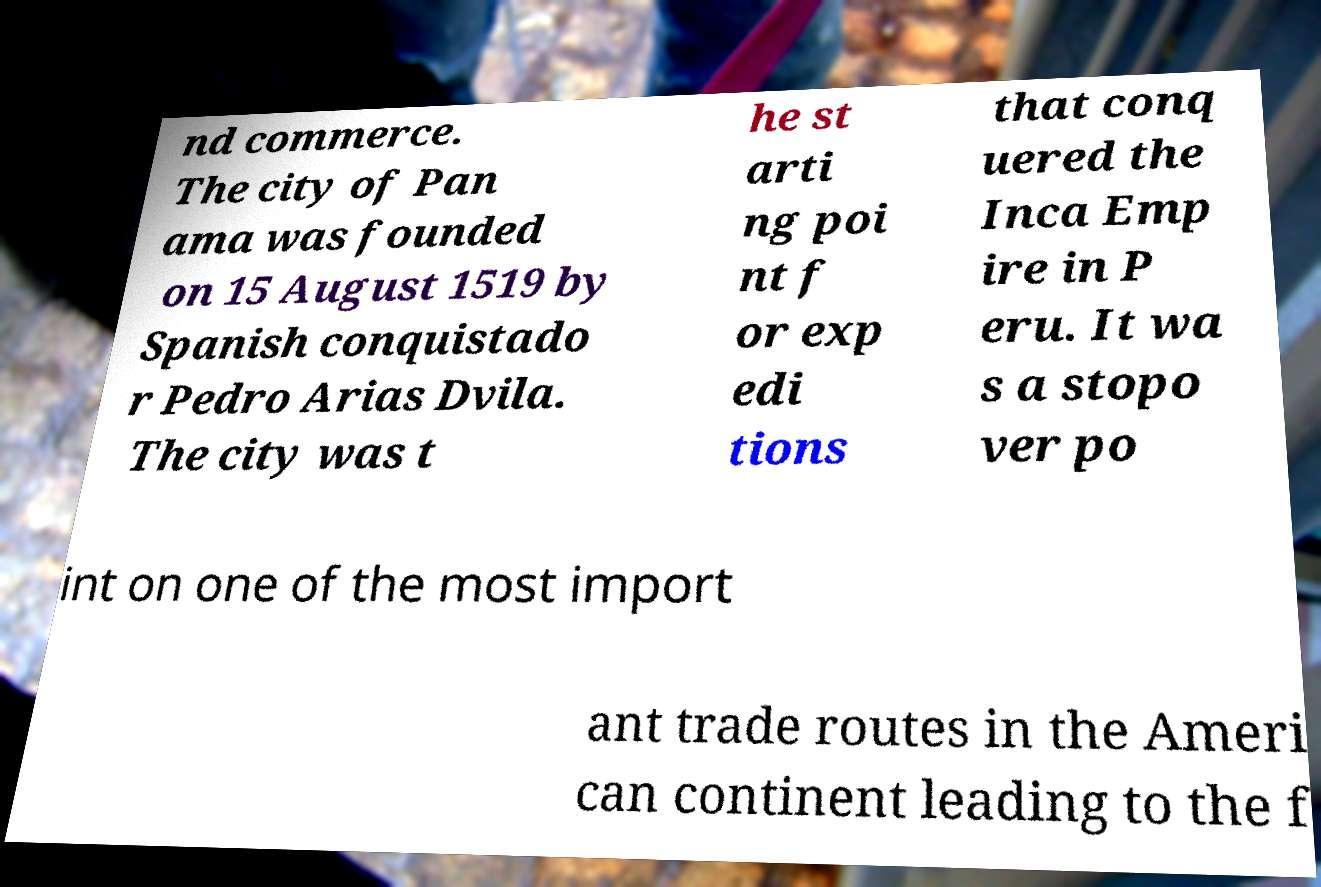Can you accurately transcribe the text from the provided image for me? nd commerce. The city of Pan ama was founded on 15 August 1519 by Spanish conquistado r Pedro Arias Dvila. The city was t he st arti ng poi nt f or exp edi tions that conq uered the Inca Emp ire in P eru. It wa s a stopo ver po int on one of the most import ant trade routes in the Ameri can continent leading to the f 